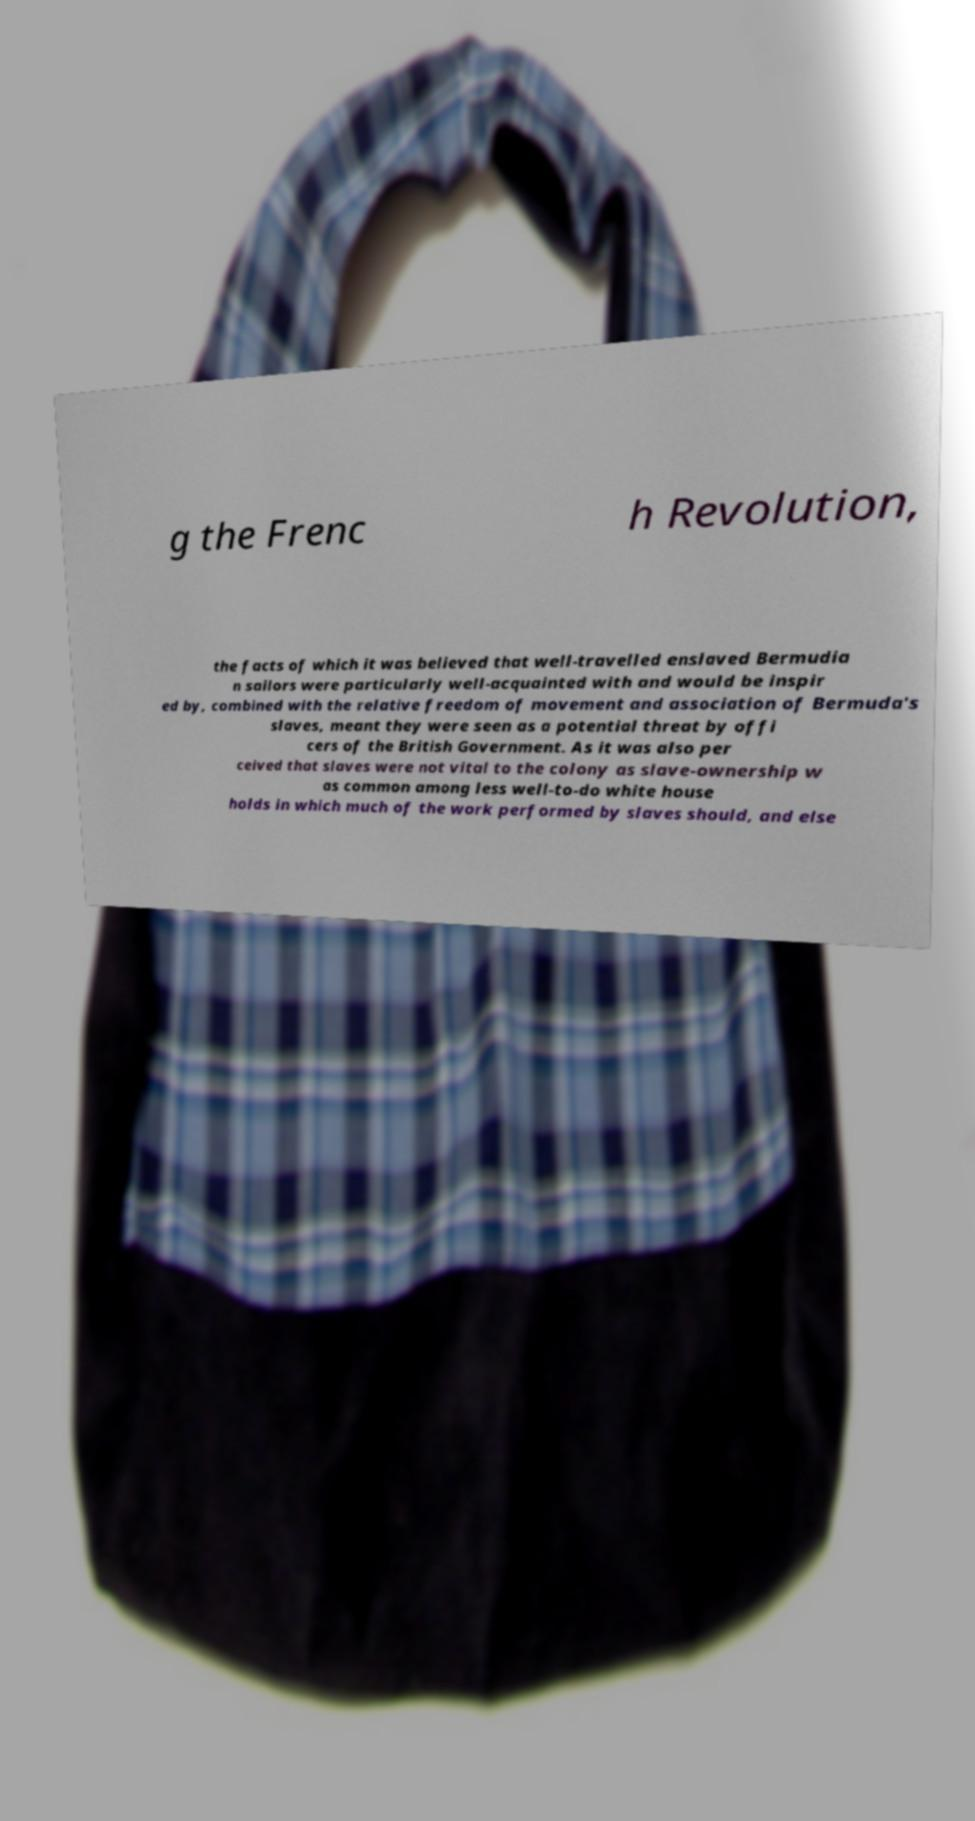For documentation purposes, I need the text within this image transcribed. Could you provide that? g the Frenc h Revolution, the facts of which it was believed that well-travelled enslaved Bermudia n sailors were particularly well-acquainted with and would be inspir ed by, combined with the relative freedom of movement and association of Bermuda's slaves, meant they were seen as a potential threat by offi cers of the British Government. As it was also per ceived that slaves were not vital to the colony as slave-ownership w as common among less well-to-do white house holds in which much of the work performed by slaves should, and else 